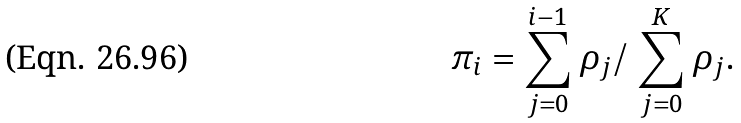Convert formula to latex. <formula><loc_0><loc_0><loc_500><loc_500>\pi _ { i } = \sum _ { j = 0 } ^ { i - 1 } \rho _ { j } / \ \sum _ { j = 0 } ^ { K } \rho _ { j } .</formula> 